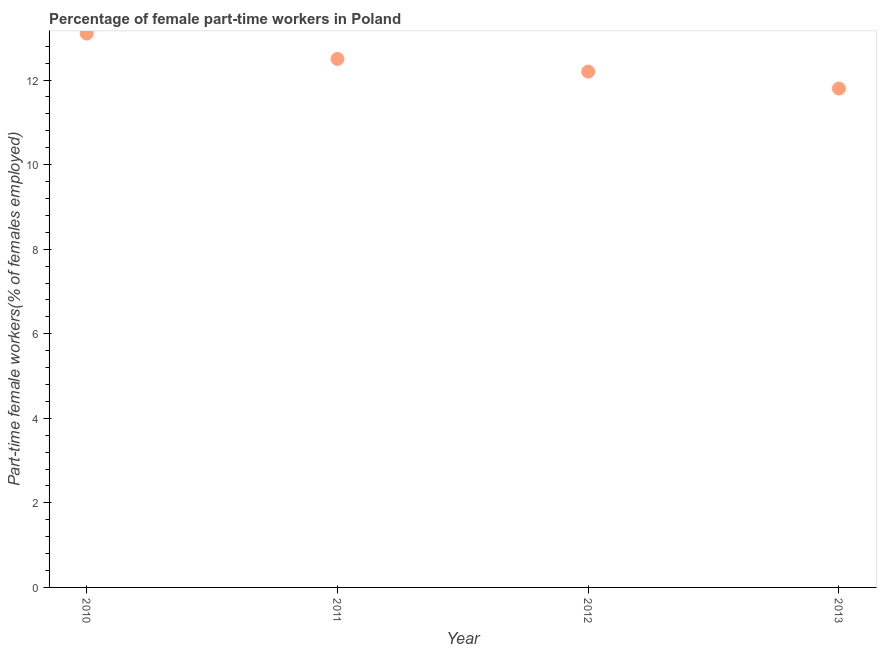What is the percentage of part-time female workers in 2011?
Provide a short and direct response. 12.5. Across all years, what is the maximum percentage of part-time female workers?
Make the answer very short. 13.1. Across all years, what is the minimum percentage of part-time female workers?
Ensure brevity in your answer.  11.8. In which year was the percentage of part-time female workers maximum?
Your response must be concise. 2010. In which year was the percentage of part-time female workers minimum?
Keep it short and to the point. 2013. What is the sum of the percentage of part-time female workers?
Ensure brevity in your answer.  49.6. What is the difference between the percentage of part-time female workers in 2010 and 2013?
Give a very brief answer. 1.3. What is the average percentage of part-time female workers per year?
Provide a short and direct response. 12.4. What is the median percentage of part-time female workers?
Provide a short and direct response. 12.35. What is the ratio of the percentage of part-time female workers in 2010 to that in 2012?
Your answer should be very brief. 1.07. Is the percentage of part-time female workers in 2011 less than that in 2012?
Offer a terse response. No. What is the difference between the highest and the second highest percentage of part-time female workers?
Offer a terse response. 0.6. Is the sum of the percentage of part-time female workers in 2012 and 2013 greater than the maximum percentage of part-time female workers across all years?
Offer a terse response. Yes. What is the difference between the highest and the lowest percentage of part-time female workers?
Keep it short and to the point. 1.3. In how many years, is the percentage of part-time female workers greater than the average percentage of part-time female workers taken over all years?
Provide a succinct answer. 2. Does the percentage of part-time female workers monotonically increase over the years?
Give a very brief answer. No. How many dotlines are there?
Offer a terse response. 1. Are the values on the major ticks of Y-axis written in scientific E-notation?
Ensure brevity in your answer.  No. Does the graph contain any zero values?
Your answer should be compact. No. What is the title of the graph?
Give a very brief answer. Percentage of female part-time workers in Poland. What is the label or title of the Y-axis?
Ensure brevity in your answer.  Part-time female workers(% of females employed). What is the Part-time female workers(% of females employed) in 2010?
Make the answer very short. 13.1. What is the Part-time female workers(% of females employed) in 2012?
Keep it short and to the point. 12.2. What is the Part-time female workers(% of females employed) in 2013?
Offer a terse response. 11.8. What is the difference between the Part-time female workers(% of females employed) in 2010 and 2012?
Give a very brief answer. 0.9. What is the difference between the Part-time female workers(% of females employed) in 2011 and 2012?
Offer a terse response. 0.3. What is the ratio of the Part-time female workers(% of females employed) in 2010 to that in 2011?
Make the answer very short. 1.05. What is the ratio of the Part-time female workers(% of females employed) in 2010 to that in 2012?
Provide a succinct answer. 1.07. What is the ratio of the Part-time female workers(% of females employed) in 2010 to that in 2013?
Ensure brevity in your answer.  1.11. What is the ratio of the Part-time female workers(% of females employed) in 2011 to that in 2013?
Offer a terse response. 1.06. What is the ratio of the Part-time female workers(% of females employed) in 2012 to that in 2013?
Provide a succinct answer. 1.03. 